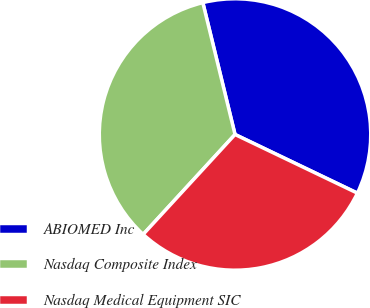<chart> <loc_0><loc_0><loc_500><loc_500><pie_chart><fcel>ABIOMED Inc<fcel>Nasdaq Composite Index<fcel>Nasdaq Medical Equipment SIC<nl><fcel>35.93%<fcel>34.36%<fcel>29.72%<nl></chart> 